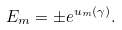Convert formula to latex. <formula><loc_0><loc_0><loc_500><loc_500>E _ { m } = \pm e ^ { u _ { m } ( \gamma ) } .</formula> 